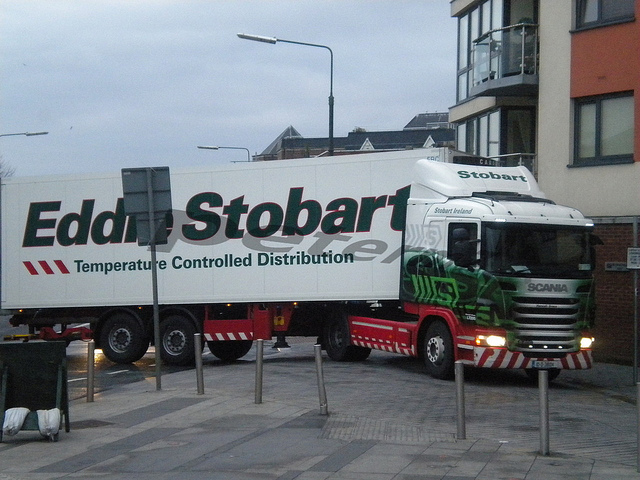What company does the truck belong to? The truck has branding indicating it belongs to 'Eddie Stobart', which is a company known for transportation and logistics services. The company operates a large fleet of trucks like the one pictured for various distribution needs. What can you deduce about the operation of this truck? Since it's labeled 'Temperature Controlled Distribution', it's specialized for carrying perishable goods that require a refrigerated or heated environment to maintain their quality during transit. The fleet number and tracking capabilities also suggest a well-organized and monitored operation typical of modern logistics companies. 